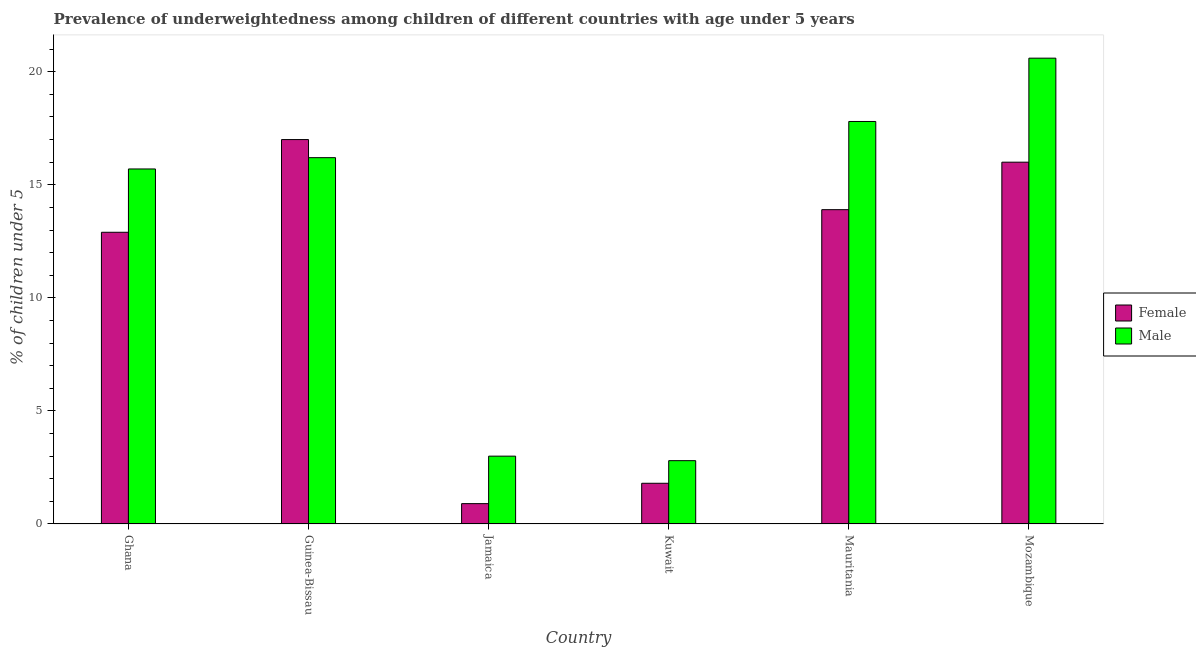Are the number of bars per tick equal to the number of legend labels?
Your answer should be compact. Yes. Are the number of bars on each tick of the X-axis equal?
Make the answer very short. Yes. What is the label of the 1st group of bars from the left?
Offer a terse response. Ghana. In how many cases, is the number of bars for a given country not equal to the number of legend labels?
Your answer should be very brief. 0. What is the percentage of underweighted male children in Guinea-Bissau?
Your answer should be compact. 16.2. Across all countries, what is the maximum percentage of underweighted male children?
Provide a succinct answer. 20.6. Across all countries, what is the minimum percentage of underweighted male children?
Your answer should be very brief. 2.8. In which country was the percentage of underweighted male children maximum?
Offer a very short reply. Mozambique. In which country was the percentage of underweighted male children minimum?
Offer a terse response. Kuwait. What is the total percentage of underweighted female children in the graph?
Give a very brief answer. 62.5. What is the difference between the percentage of underweighted female children in Mauritania and that in Mozambique?
Offer a very short reply. -2.1. What is the difference between the percentage of underweighted female children in Mozambique and the percentage of underweighted male children in Jamaica?
Make the answer very short. 13. What is the average percentage of underweighted male children per country?
Keep it short and to the point. 12.68. What is the difference between the percentage of underweighted female children and percentage of underweighted male children in Mauritania?
Ensure brevity in your answer.  -3.9. In how many countries, is the percentage of underweighted female children greater than 11 %?
Offer a terse response. 4. What is the ratio of the percentage of underweighted male children in Guinea-Bissau to that in Jamaica?
Offer a terse response. 5.4. What is the difference between the highest and the second highest percentage of underweighted male children?
Make the answer very short. 2.8. What is the difference between the highest and the lowest percentage of underweighted female children?
Your answer should be very brief. 16.1. In how many countries, is the percentage of underweighted female children greater than the average percentage of underweighted female children taken over all countries?
Your answer should be compact. 4. What does the 2nd bar from the left in Ghana represents?
Offer a very short reply. Male. What does the 1st bar from the right in Guinea-Bissau represents?
Your answer should be very brief. Male. How many bars are there?
Provide a succinct answer. 12. Are all the bars in the graph horizontal?
Ensure brevity in your answer.  No. Where does the legend appear in the graph?
Ensure brevity in your answer.  Center right. What is the title of the graph?
Make the answer very short. Prevalence of underweightedness among children of different countries with age under 5 years. What is the label or title of the Y-axis?
Make the answer very short.  % of children under 5. What is the  % of children under 5 of Female in Ghana?
Provide a short and direct response. 12.9. What is the  % of children under 5 in Male in Ghana?
Provide a short and direct response. 15.7. What is the  % of children under 5 of Male in Guinea-Bissau?
Your answer should be compact. 16.2. What is the  % of children under 5 in Female in Jamaica?
Give a very brief answer. 0.9. What is the  % of children under 5 in Male in Jamaica?
Ensure brevity in your answer.  3. What is the  % of children under 5 in Female in Kuwait?
Keep it short and to the point. 1.8. What is the  % of children under 5 of Male in Kuwait?
Your answer should be compact. 2.8. What is the  % of children under 5 in Female in Mauritania?
Make the answer very short. 13.9. What is the  % of children under 5 of Male in Mauritania?
Keep it short and to the point. 17.8. What is the  % of children under 5 in Female in Mozambique?
Provide a succinct answer. 16. What is the  % of children under 5 of Male in Mozambique?
Keep it short and to the point. 20.6. Across all countries, what is the maximum  % of children under 5 of Female?
Offer a terse response. 17. Across all countries, what is the maximum  % of children under 5 of Male?
Make the answer very short. 20.6. Across all countries, what is the minimum  % of children under 5 of Female?
Ensure brevity in your answer.  0.9. Across all countries, what is the minimum  % of children under 5 in Male?
Your response must be concise. 2.8. What is the total  % of children under 5 of Female in the graph?
Provide a short and direct response. 62.5. What is the total  % of children under 5 of Male in the graph?
Provide a short and direct response. 76.1. What is the difference between the  % of children under 5 in Female in Ghana and that in Guinea-Bissau?
Provide a succinct answer. -4.1. What is the difference between the  % of children under 5 of Female in Ghana and that in Jamaica?
Ensure brevity in your answer.  12. What is the difference between the  % of children under 5 in Female in Ghana and that in Mauritania?
Keep it short and to the point. -1. What is the difference between the  % of children under 5 of Male in Ghana and that in Mauritania?
Provide a succinct answer. -2.1. What is the difference between the  % of children under 5 in Female in Ghana and that in Mozambique?
Your answer should be compact. -3.1. What is the difference between the  % of children under 5 of Female in Guinea-Bissau and that in Jamaica?
Give a very brief answer. 16.1. What is the difference between the  % of children under 5 of Male in Guinea-Bissau and that in Jamaica?
Provide a short and direct response. 13.2. What is the difference between the  % of children under 5 of Female in Guinea-Bissau and that in Mozambique?
Provide a short and direct response. 1. What is the difference between the  % of children under 5 of Female in Jamaica and that in Kuwait?
Ensure brevity in your answer.  -0.9. What is the difference between the  % of children under 5 in Male in Jamaica and that in Mauritania?
Your answer should be compact. -14.8. What is the difference between the  % of children under 5 of Female in Jamaica and that in Mozambique?
Your response must be concise. -15.1. What is the difference between the  % of children under 5 of Male in Jamaica and that in Mozambique?
Offer a very short reply. -17.6. What is the difference between the  % of children under 5 in Female in Kuwait and that in Mauritania?
Offer a terse response. -12.1. What is the difference between the  % of children under 5 in Male in Kuwait and that in Mauritania?
Keep it short and to the point. -15. What is the difference between the  % of children under 5 of Male in Kuwait and that in Mozambique?
Your answer should be compact. -17.8. What is the difference between the  % of children under 5 of Male in Mauritania and that in Mozambique?
Ensure brevity in your answer.  -2.8. What is the difference between the  % of children under 5 in Female in Ghana and the  % of children under 5 in Male in Guinea-Bissau?
Provide a succinct answer. -3.3. What is the difference between the  % of children under 5 of Female in Ghana and the  % of children under 5 of Male in Mauritania?
Your answer should be compact. -4.9. What is the difference between the  % of children under 5 of Female in Ghana and the  % of children under 5 of Male in Mozambique?
Offer a very short reply. -7.7. What is the difference between the  % of children under 5 in Female in Guinea-Bissau and the  % of children under 5 in Male in Mauritania?
Offer a very short reply. -0.8. What is the difference between the  % of children under 5 of Female in Guinea-Bissau and the  % of children under 5 of Male in Mozambique?
Provide a short and direct response. -3.6. What is the difference between the  % of children under 5 in Female in Jamaica and the  % of children under 5 in Male in Mauritania?
Keep it short and to the point. -16.9. What is the difference between the  % of children under 5 in Female in Jamaica and the  % of children under 5 in Male in Mozambique?
Give a very brief answer. -19.7. What is the difference between the  % of children under 5 of Female in Kuwait and the  % of children under 5 of Male in Mauritania?
Offer a terse response. -16. What is the difference between the  % of children under 5 of Female in Kuwait and the  % of children under 5 of Male in Mozambique?
Make the answer very short. -18.8. What is the average  % of children under 5 in Female per country?
Provide a succinct answer. 10.42. What is the average  % of children under 5 of Male per country?
Provide a short and direct response. 12.68. What is the difference between the  % of children under 5 in Female and  % of children under 5 in Male in Guinea-Bissau?
Keep it short and to the point. 0.8. What is the difference between the  % of children under 5 of Female and  % of children under 5 of Male in Mauritania?
Make the answer very short. -3.9. What is the ratio of the  % of children under 5 of Female in Ghana to that in Guinea-Bissau?
Give a very brief answer. 0.76. What is the ratio of the  % of children under 5 in Male in Ghana to that in Guinea-Bissau?
Your response must be concise. 0.97. What is the ratio of the  % of children under 5 in Female in Ghana to that in Jamaica?
Offer a very short reply. 14.33. What is the ratio of the  % of children under 5 of Male in Ghana to that in Jamaica?
Provide a succinct answer. 5.23. What is the ratio of the  % of children under 5 of Female in Ghana to that in Kuwait?
Keep it short and to the point. 7.17. What is the ratio of the  % of children under 5 of Male in Ghana to that in Kuwait?
Give a very brief answer. 5.61. What is the ratio of the  % of children under 5 in Female in Ghana to that in Mauritania?
Make the answer very short. 0.93. What is the ratio of the  % of children under 5 of Male in Ghana to that in Mauritania?
Provide a succinct answer. 0.88. What is the ratio of the  % of children under 5 in Female in Ghana to that in Mozambique?
Ensure brevity in your answer.  0.81. What is the ratio of the  % of children under 5 in Male in Ghana to that in Mozambique?
Offer a terse response. 0.76. What is the ratio of the  % of children under 5 of Female in Guinea-Bissau to that in Jamaica?
Offer a terse response. 18.89. What is the ratio of the  % of children under 5 in Male in Guinea-Bissau to that in Jamaica?
Offer a terse response. 5.4. What is the ratio of the  % of children under 5 of Female in Guinea-Bissau to that in Kuwait?
Give a very brief answer. 9.44. What is the ratio of the  % of children under 5 in Male in Guinea-Bissau to that in Kuwait?
Offer a terse response. 5.79. What is the ratio of the  % of children under 5 of Female in Guinea-Bissau to that in Mauritania?
Provide a succinct answer. 1.22. What is the ratio of the  % of children under 5 of Male in Guinea-Bissau to that in Mauritania?
Provide a succinct answer. 0.91. What is the ratio of the  % of children under 5 of Female in Guinea-Bissau to that in Mozambique?
Your answer should be very brief. 1.06. What is the ratio of the  % of children under 5 in Male in Guinea-Bissau to that in Mozambique?
Give a very brief answer. 0.79. What is the ratio of the  % of children under 5 of Male in Jamaica to that in Kuwait?
Provide a succinct answer. 1.07. What is the ratio of the  % of children under 5 of Female in Jamaica to that in Mauritania?
Your answer should be very brief. 0.06. What is the ratio of the  % of children under 5 of Male in Jamaica to that in Mauritania?
Provide a succinct answer. 0.17. What is the ratio of the  % of children under 5 in Female in Jamaica to that in Mozambique?
Your answer should be compact. 0.06. What is the ratio of the  % of children under 5 of Male in Jamaica to that in Mozambique?
Your response must be concise. 0.15. What is the ratio of the  % of children under 5 in Female in Kuwait to that in Mauritania?
Offer a very short reply. 0.13. What is the ratio of the  % of children under 5 in Male in Kuwait to that in Mauritania?
Keep it short and to the point. 0.16. What is the ratio of the  % of children under 5 in Female in Kuwait to that in Mozambique?
Make the answer very short. 0.11. What is the ratio of the  % of children under 5 in Male in Kuwait to that in Mozambique?
Provide a short and direct response. 0.14. What is the ratio of the  % of children under 5 in Female in Mauritania to that in Mozambique?
Provide a short and direct response. 0.87. What is the ratio of the  % of children under 5 in Male in Mauritania to that in Mozambique?
Make the answer very short. 0.86. What is the difference between the highest and the second highest  % of children under 5 in Male?
Keep it short and to the point. 2.8. What is the difference between the highest and the lowest  % of children under 5 in Female?
Your response must be concise. 16.1. 